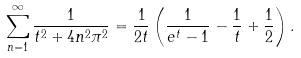<formula> <loc_0><loc_0><loc_500><loc_500>\sum _ { n = 1 } ^ { \infty } \frac { 1 } { t ^ { 2 } + 4 n ^ { 2 } \pi ^ { 2 } } = \frac { 1 } { 2 t } \left ( \frac { 1 } { e ^ { t } - 1 } - \frac { 1 } { t } + \frac { 1 } { 2 } \right ) .</formula> 